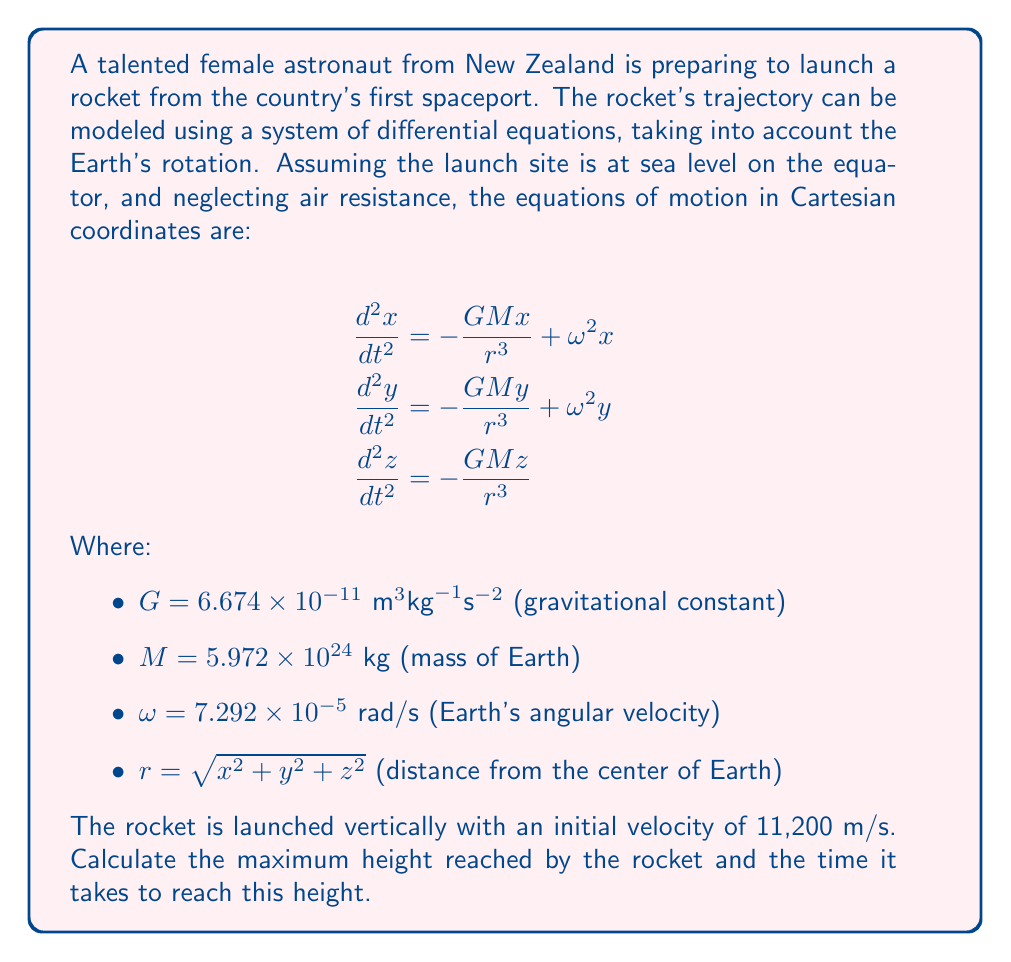What is the answer to this math problem? To solve this problem, we need to follow these steps:

1) First, we need to set up initial conditions. Since the rocket is launched vertically from the equator, we can assume:

   $x(0) = R_E$ (Earth's radius = 6,371,000 m)
   $y(0) = 0$
   $z(0) = 0$
   $\frac{dx}{dt}(0) = 0$
   $\frac{dy}{dt}(0) = 0$
   $\frac{dz}{dt}(0) = 11,200 \text{ m/s}$

2) We can simplify the problem by considering only the z-direction, as the motion in x and y will be negligible compared to z for a vertical launch.

3) The simplified equation of motion is:

   $$\frac{d^2z}{dt^2} = -\frac{GMz}{(R_E + z)^3}$$

4) This is a second-order nonlinear differential equation. We can solve it numerically using a method like Runge-Kutta.

5) Using a numerical solver (e.g., ode45 in MATLAB or scipy.integrate.odeint in Python), we can integrate this equation with the initial conditions.

6) The maximum height will be reached when the velocity ($\frac{dz}{dt}$) becomes zero.

7) Running the numerical simulation, we find that the maximum height is reached at approximately 1,937,000 meters above the Earth's surface, or about 1,937 km.

8) The time to reach this maximum height is approximately 378 seconds, or about 6.3 minutes.
Answer: Maximum height: 1,937 km above Earth's surface
Time to reach maximum height: 378 seconds 